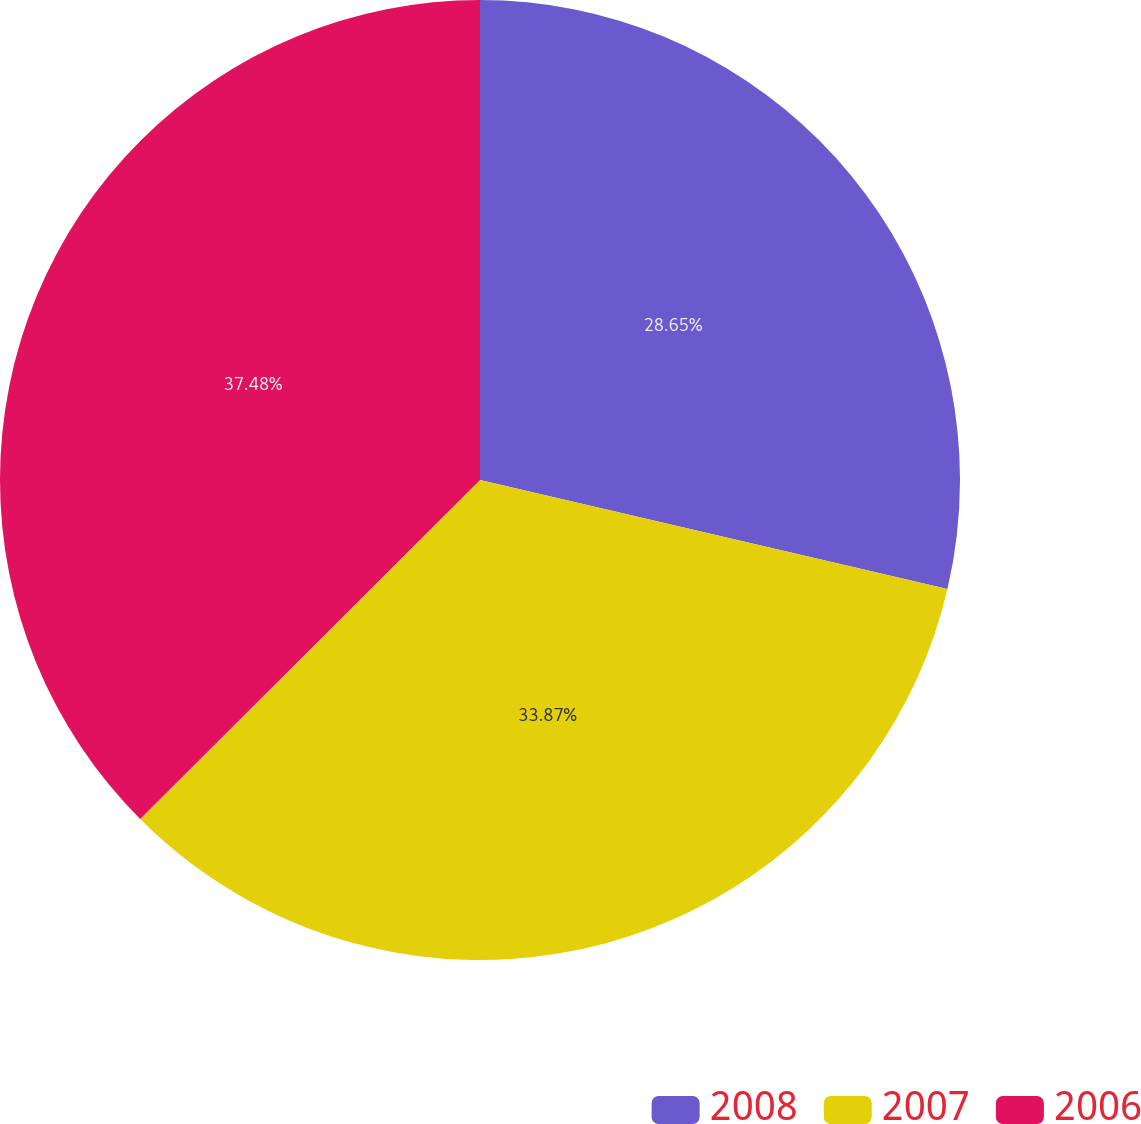Convert chart. <chart><loc_0><loc_0><loc_500><loc_500><pie_chart><fcel>2008<fcel>2007<fcel>2006<nl><fcel>28.65%<fcel>33.87%<fcel>37.48%<nl></chart> 